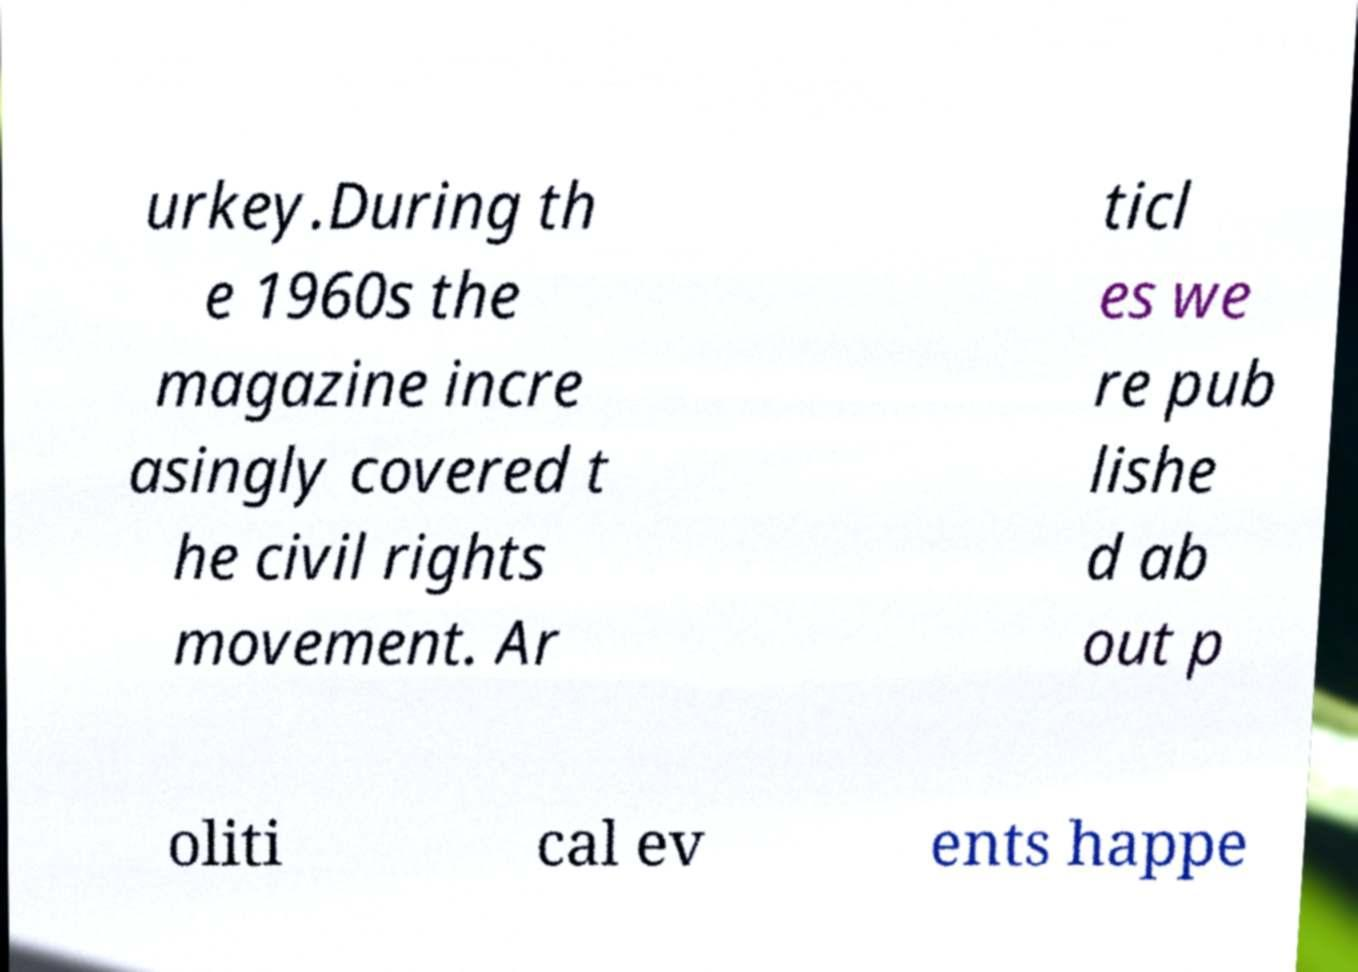Could you extract and type out the text from this image? urkey.During th e 1960s the magazine incre asingly covered t he civil rights movement. Ar ticl es we re pub lishe d ab out p oliti cal ev ents happe 